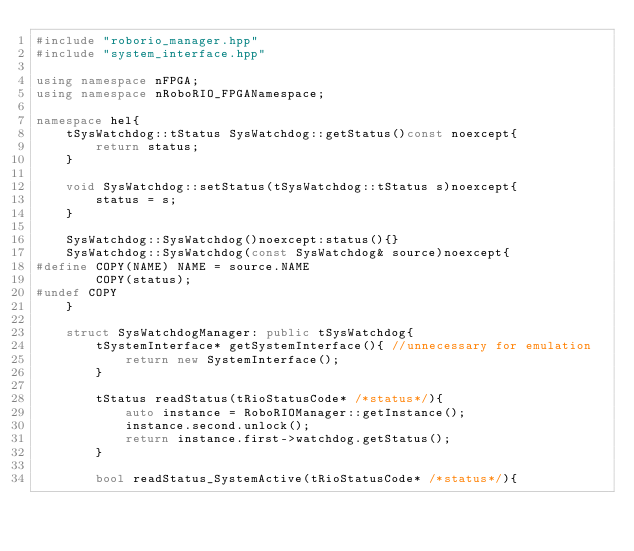<code> <loc_0><loc_0><loc_500><loc_500><_C++_>#include "roborio_manager.hpp"
#include "system_interface.hpp"

using namespace nFPGA;
using namespace nRoboRIO_FPGANamespace;

namespace hel{
    tSysWatchdog::tStatus SysWatchdog::getStatus()const noexcept{
        return status;
    }

    void SysWatchdog::setStatus(tSysWatchdog::tStatus s)noexcept{
        status = s;
    }

    SysWatchdog::SysWatchdog()noexcept:status(){}
    SysWatchdog::SysWatchdog(const SysWatchdog& source)noexcept{
#define COPY(NAME) NAME = source.NAME
        COPY(status);
#undef COPY
    }

    struct SysWatchdogManager: public tSysWatchdog{
        tSystemInterface* getSystemInterface(){ //unnecessary for emulation
            return new SystemInterface();
        }

        tStatus readStatus(tRioStatusCode* /*status*/){
            auto instance = RoboRIOManager::getInstance();
            instance.second.unlock();
            return instance.first->watchdog.getStatus();
        }

        bool readStatus_SystemActive(tRioStatusCode* /*status*/){</code> 